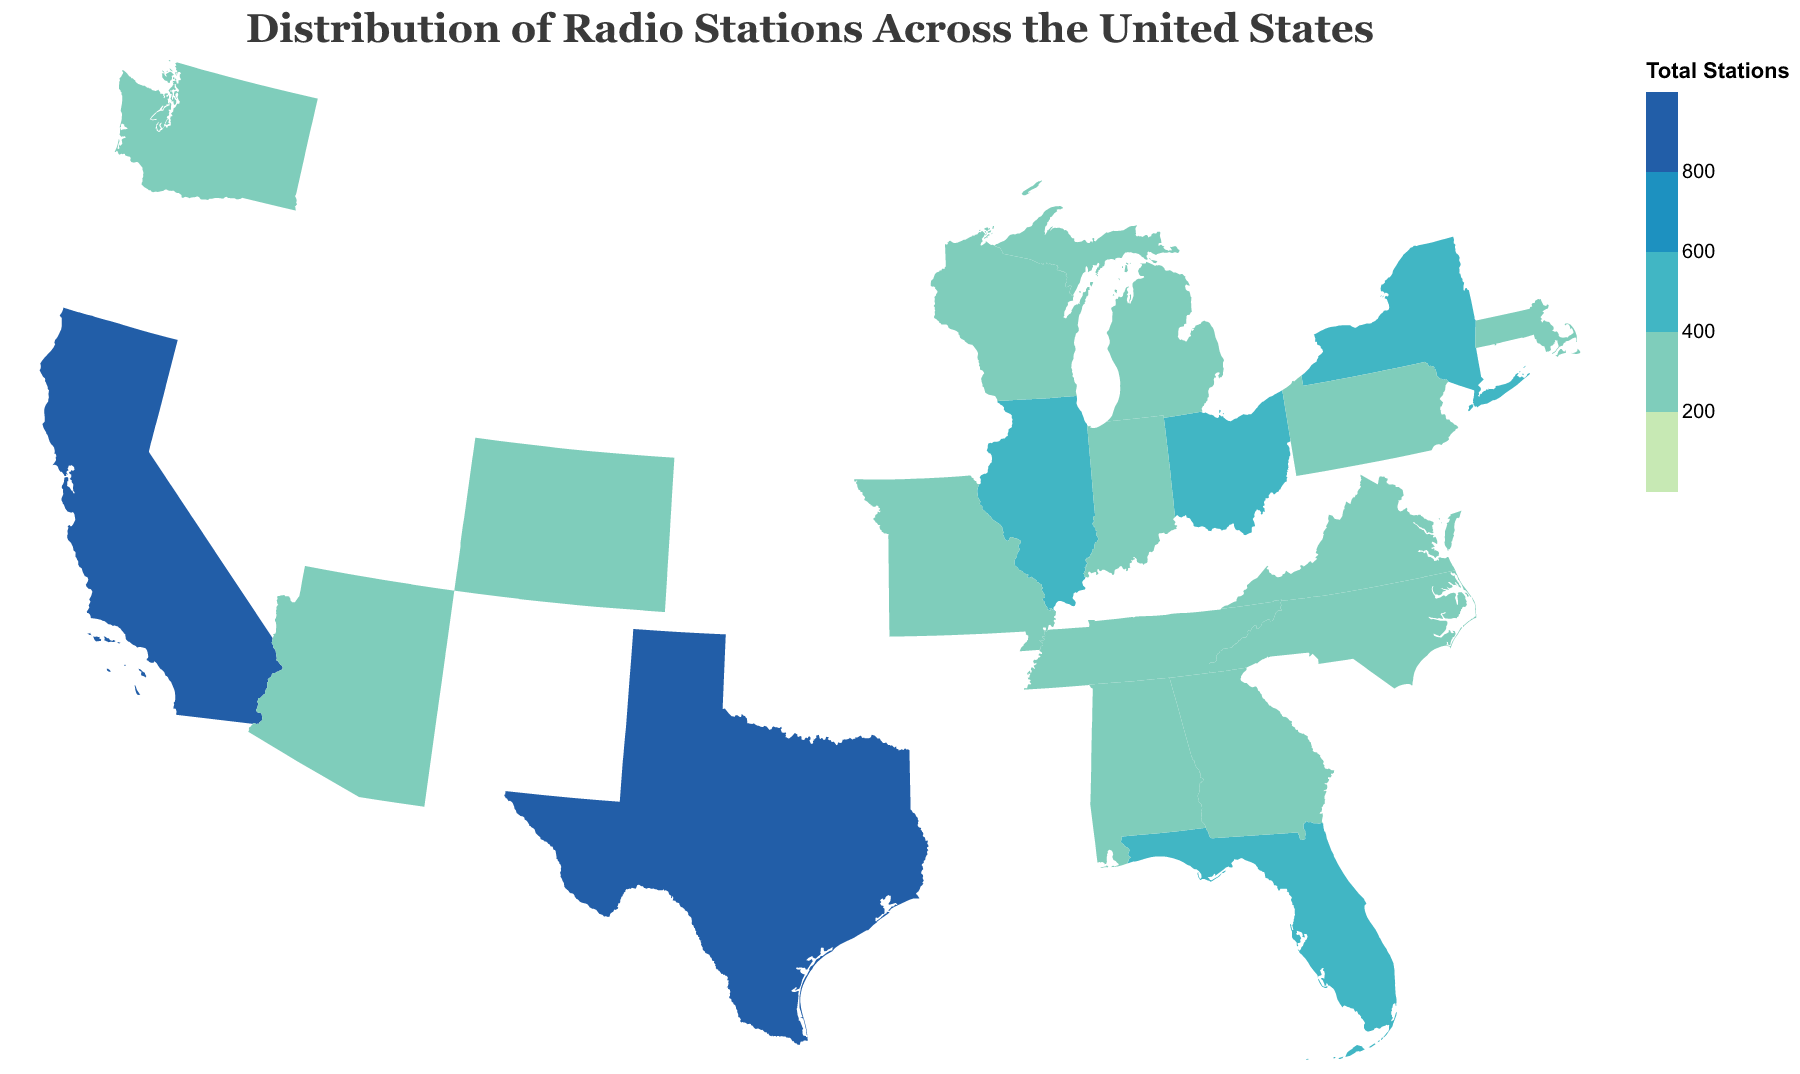What is the title of the figure? The title of the figure is usually displayed prominently at the top and provides context about the data being visualized. In this case, it is "Distribution of Radio Stations Across the United States".
Answer: Distribution of Radio Stations Across the United States Which state has the highest number of AM Radio Stations? To determine this, look at the "AM Stations" column and find the highest value. Texas has the highest number of AM Stations, which is 240.
Answer: Texas How many total radio stations are there in Illinois? Look at the state Illinois and check the "Total Stations" column, which shows there are 440 total radio stations.
Answer: 440 What color represents states with more than 800 total stations on the map? Check the color scale provided in the figure. States with more than 800 total stations are represented by a dark blue color.
Answer: dark blue What's the combined total of radio stations in California and Florida? Add the total stations for California (895) and Florida (585). 895 + 585 = 1480.
Answer: 1480 Which state has more FM Stations: Georgia or Ohio? Compare the "FM Stations" column for Georgia (285) and Ohio (310). Ohio has more FM Stations.
Answer: Ohio What is the difference in the number of total radio stations between New York and Pennsylvania? Subtract the total stations in Pennsylvania (395) from those in New York (500). 500 - 395 = 105.
Answer: 105 How many states have between 200 and 400 total radio stations? Count the number of states where the "Total Stations" fall within the range 200 to 400, inclusive. The states are Pennsylvania, Georgia, Michigan, North Carolina, Virginia, Tennessee, Indiana, Missouri, Wisconsin, Washington, Colorado, Arizona, and Massachusetts—thirteen states in total.
Answer: 13 Which states have exactly 895 total stations, and how did you identify them? Look at the "Total Stations" column and identify the states that show a value of 895. These states are California and Texas.
Answer: California, Texas What is the median number of total radio stations across all listed states? First, arrange the number of total stations in ascending order: 205, 215, 230, 240, 250, 265, 280, 290, 300, 315, 350, 360, 375, 395, 415, 440, 500, 585, 895, 895. Since there are 20 states, the median will be the average of the 10th and 11th values, which are 315 and 350. (315 + 350) / 2 = 332.5
Answer: 332.5 